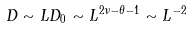<formula> <loc_0><loc_0><loc_500><loc_500>D \sim L D _ { 0 } \sim L ^ { 2 \nu - \theta - 1 } \sim L ^ { - 2 }</formula> 